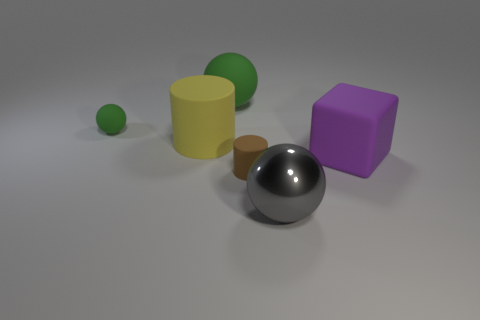What material is the green thing right of the small object left of the cylinder behind the tiny brown rubber object?
Provide a short and direct response. Rubber. Is the number of things left of the tiny green matte object greater than the number of big matte spheres that are right of the large purple matte object?
Offer a very short reply. No. What number of small objects have the same material as the big cube?
Offer a very short reply. 2. Do the thing that is on the right side of the gray metallic ball and the tiny object on the left side of the small brown rubber cylinder have the same shape?
Your answer should be very brief. No. What color is the tiny matte thing that is left of the small brown object?
Your answer should be very brief. Green. Are there any tiny brown matte objects that have the same shape as the large green matte object?
Your answer should be very brief. No. What material is the big green object?
Your answer should be very brief. Rubber. There is a object that is both behind the brown rubber cylinder and right of the small brown cylinder; what is its size?
Your answer should be very brief. Large. What material is the big object that is the same color as the small rubber ball?
Provide a succinct answer. Rubber. What number of green matte objects are there?
Offer a terse response. 2. 